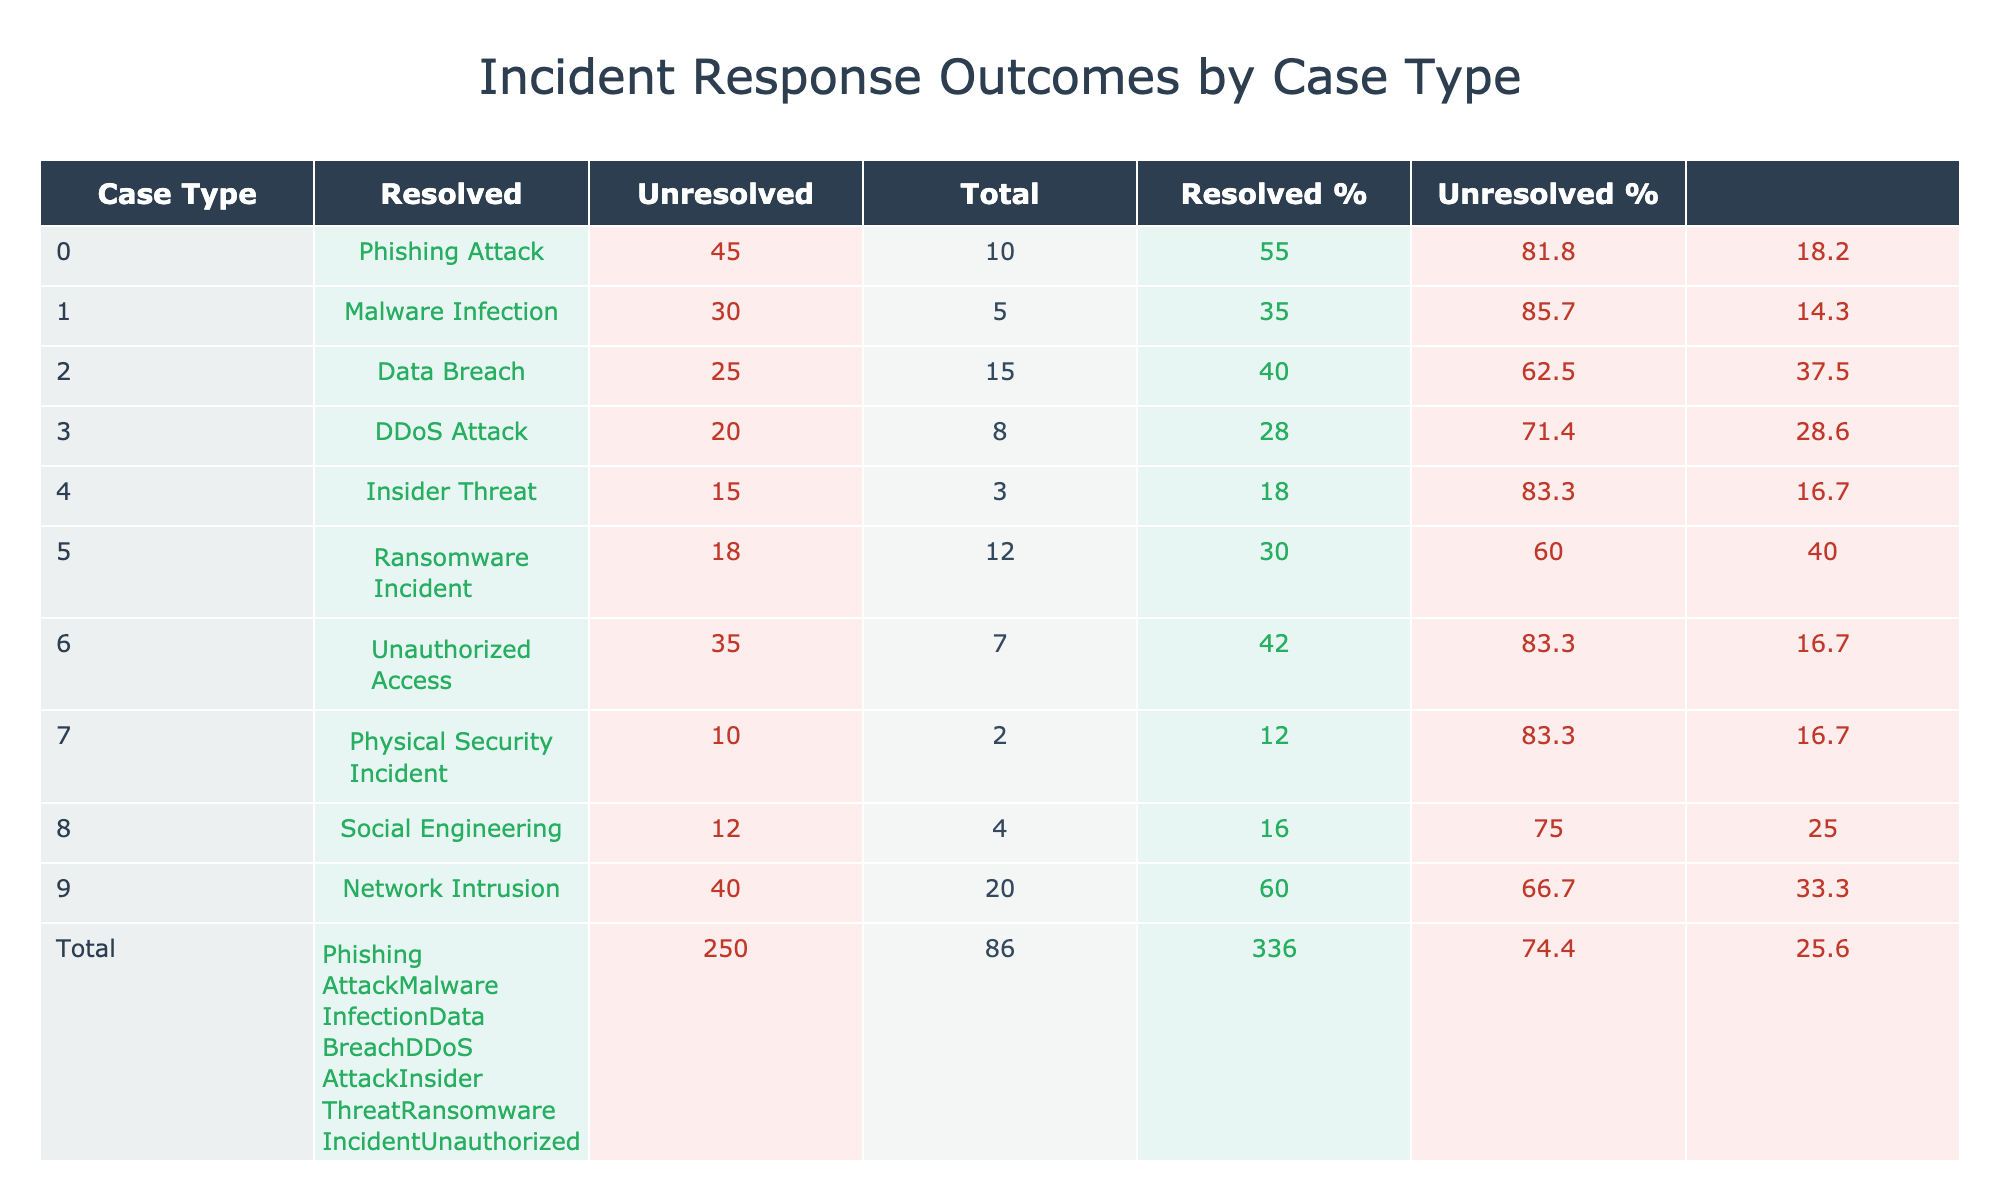What is the total number of resolved cases across all case types? To find the total resolved cases, sum the 'Resolved' column values. That gives: 45 + 30 + 25 + 20 + 15 + 18 + 35 + 10 + 12 + 40 =  310.
Answer: 310 What is the percentage of unresolved cases for the Data Breach case type? The unresolved cases for Data Breach are 15, and the total number of cases is 25 (resolved) + 15 (unresolved) = 40. The percentage calculated as (15/40) * 100 = 37.5%.
Answer: 37.5% Which case type has the highest resolution percentage? First, calculate the resolution percentage for each case type (Resolved/Total * 100). Phishing Attack has the highest percentage at (45/(45+10)) * 100 = 81.8%.
Answer: Phishing Attack Are there more resolved cases for Network Intrusion than for Ransomware Incident? The resolved cases are 40 for Network Intrusion and 18 for Ransomware Incident, which means Network Intrusion has more resolved cases.
Answer: Yes What is the total number of unresolved cases across all case types? To find total unresolved cases, sum the 'Unresolved' column values: 10 + 5 + 15 + 8 + 3 + 12 + 7 + 2 + 4 + 20 = 82.
Answer: 82 Which case type has the second highest number of resolved cases? After analyzing the resolved cases: Phishing Attack (45), Network Intrusion (40), Unauthorized Access (35), Malware Infection (30), and Ransomware Incident (18), it is clear that Network Intrusion has the second highest.
Answer: Network Intrusion What is the average percentage of resolved cases across all types? First, calculate each percentage for resolved cases. The percentages are approximately: 81.8%, 85.7%, 62.5%, 71.4%, 83.3%, 60%, 83.3%, 83.3%, 75%, and 66.7%. Averaging them gives: (81.8 + 85.7 + 62.5 + 71.4 + 83.3 + 60 + 83.3 + 83.3 + 75 + 66.7) / 10 = 72.6%.
Answer: 72.6% Does the case type "Insider Threat" have a higher number of unresolved cases compared to "Physical Security Incident"? The unresolved cases for Insider Threat is 3, while for Physical Security Incident it is 2. Hence, Insider Threat has a higher number of unresolved cases.
Answer: Yes What is the total number of cases for the case type with the least resolved cases? The case type with the least resolved cases is "Physical Security Incident" with 10 resolved cases and 2 unresolved cases, making the total 10 + 2 = 12.
Answer: 12 